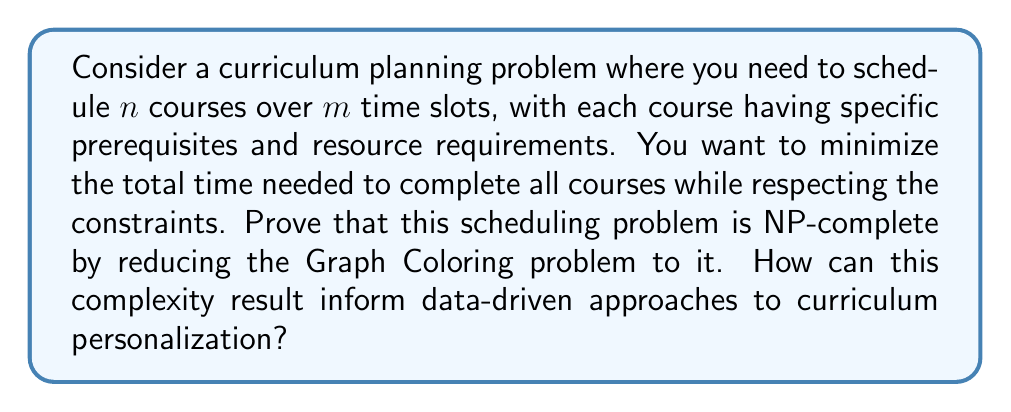Provide a solution to this math problem. To prove that the curriculum scheduling problem is NP-complete, we need to show that it is in NP and that it is NP-hard. We'll do this by reducing the Graph Coloring problem, which is known to be NP-complete, to our scheduling problem.

1. Show that the problem is in NP:
   A solution to the scheduling problem can be verified in polynomial time by checking if all courses are scheduled, prerequisites are met, and resource constraints are satisfied. This verifies that the problem is in NP.

2. Reduce Graph Coloring to Curriculum Scheduling:
   Given a graph $G=(V,E)$ to be colored with $k$ colors, we construct a curriculum scheduling instance as follows:
   - Create a course for each vertex in $V$
   - Set the number of time slots $m = k$
   - For each edge $(u,v) \in E$, add a constraint that courses $u$ and $v$ cannot be scheduled in the same time slot
   - Set all courses to have the same duration and no prerequisites

3. Prove the reduction:
   - If $G$ can be colored with $k$ colors, then the courses can be scheduled in $k$ time slots
   - If the courses can be scheduled in $k$ time slots, then $G$ can be colored with $k$ colors
   - The reduction can be done in polynomial time

4. Conclusion:
   Since Graph Coloring reduces to Curriculum Scheduling, and Graph Coloring is NP-complete, Curriculum Scheduling is NP-hard. Combined with being in NP, this proves that Curriculum Scheduling is NP-complete.

Implications for data-driven curriculum personalization:
1. Optimal solutions may be computationally infeasible for large-scale problems
2. Heuristic algorithms and approximation methods should be considered
3. Data can be used to inform constraint relaxation and prioritization
4. Incremental scheduling approaches may be more practical for personalization
5. Machine learning techniques could be employed to predict effective schedules based on historical data
Answer: The curriculum scheduling problem is NP-complete. This result implies that finding optimal personalized curricula for large numbers of students and courses is computationally intractable. Educators should focus on developing efficient heuristics, leveraging data to inform approximation strategies, and considering incremental or adaptive scheduling approaches for curriculum personalization. 